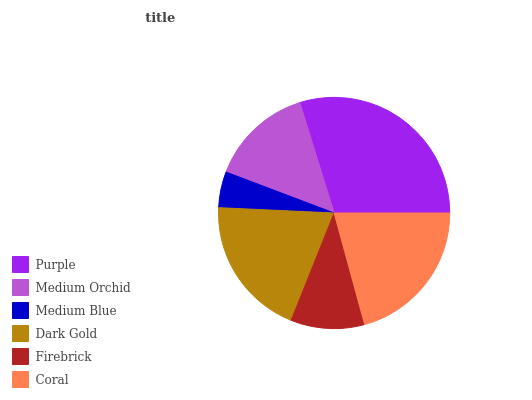Is Medium Blue the minimum?
Answer yes or no. Yes. Is Purple the maximum?
Answer yes or no. Yes. Is Medium Orchid the minimum?
Answer yes or no. No. Is Medium Orchid the maximum?
Answer yes or no. No. Is Purple greater than Medium Orchid?
Answer yes or no. Yes. Is Medium Orchid less than Purple?
Answer yes or no. Yes. Is Medium Orchid greater than Purple?
Answer yes or no. No. Is Purple less than Medium Orchid?
Answer yes or no. No. Is Dark Gold the high median?
Answer yes or no. Yes. Is Medium Orchid the low median?
Answer yes or no. Yes. Is Coral the high median?
Answer yes or no. No. Is Firebrick the low median?
Answer yes or no. No. 